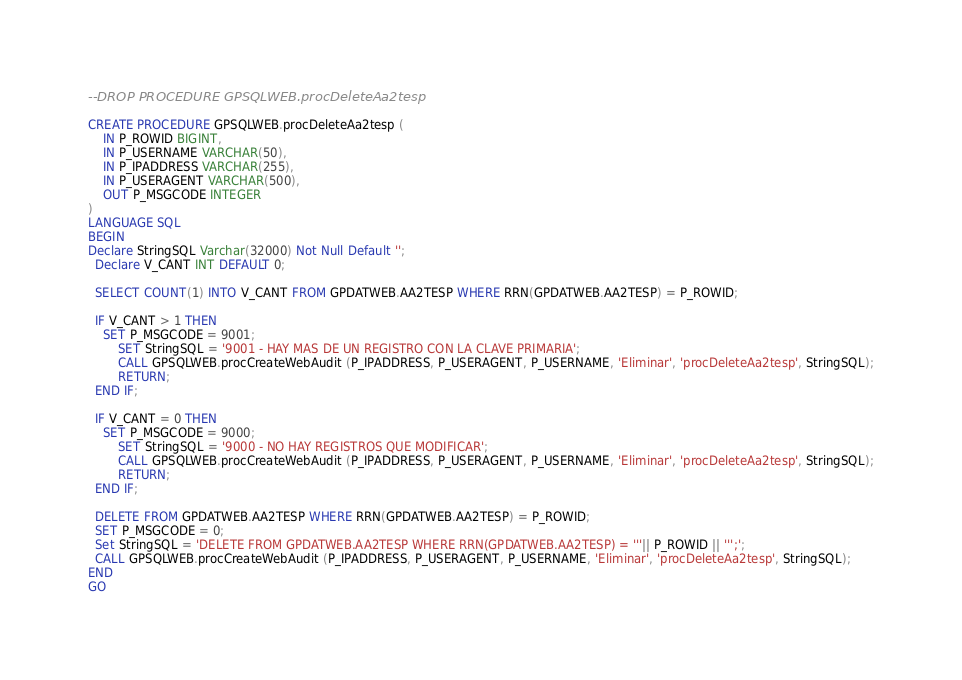<code> <loc_0><loc_0><loc_500><loc_500><_SQL_>
--DROP PROCEDURE GPSQLWEB.procDeleteAa2tesp

CREATE PROCEDURE GPSQLWEB.procDeleteAa2tesp (
    IN P_ROWID BIGINT,
    IN P_USERNAME VARCHAR(50),
    IN P_IPADDRESS VARCHAR(255),
    IN P_USERAGENT VARCHAR(500),
    OUT P_MSGCODE INTEGER
)
LANGUAGE SQL
BEGIN
Declare StringSQL Varchar(32000) Not Null Default '';
  Declare V_CANT INT DEFAULT 0;
  
  SELECT COUNT(1) INTO V_CANT FROM GPDATWEB.AA2TESP WHERE RRN(GPDATWEB.AA2TESP) = P_ROWID;

  IF V_CANT > 1 THEN
	SET P_MSGCODE = 9001;
        SET StringSQL = '9001 - HAY MAS DE UN REGISTRO CON LA CLAVE PRIMARIA';
        CALL GPSQLWEB.procCreateWebAudit (P_IPADDRESS, P_USERAGENT, P_USERNAME, 'Eliminar', 'procDeleteAa2tesp', StringSQL);
        RETURN;
  END IF;

  IF V_CANT = 0 THEN
	SET P_MSGCODE = 9000;
        SET StringSQL = '9000 - NO HAY REGISTROS QUE MODIFICAR';
        CALL GPSQLWEB.procCreateWebAudit (P_IPADDRESS, P_USERAGENT, P_USERNAME, 'Eliminar', 'procDeleteAa2tesp', StringSQL);
        RETURN;
  END IF;
  
  DELETE FROM GPDATWEB.AA2TESP WHERE RRN(GPDATWEB.AA2TESP) = P_ROWID;
  SET P_MSGCODE = 0;
  Set StringSQL = 'DELETE FROM GPDATWEB.AA2TESP WHERE RRN(GPDATWEB.AA2TESP) = '''|| P_ROWID || ''';';
  CALL GPSQLWEB.procCreateWebAudit (P_IPADDRESS, P_USERAGENT, P_USERNAME, 'Eliminar', 'procDeleteAa2tesp', StringSQL);
END
GO
</code> 